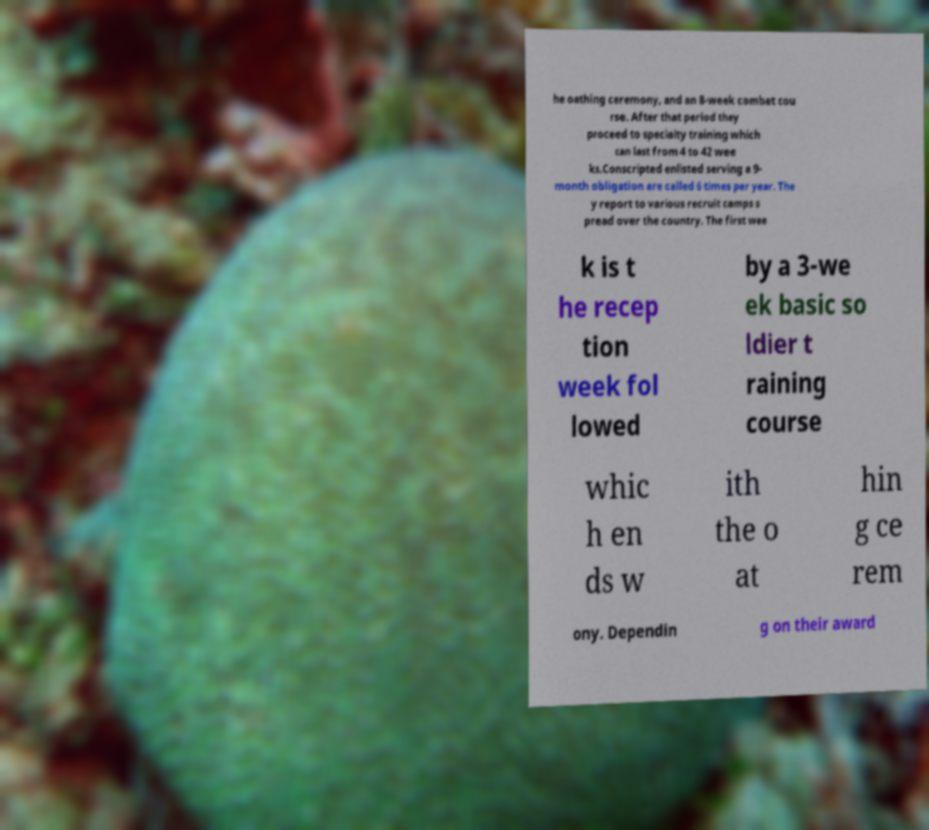Could you assist in decoding the text presented in this image and type it out clearly? he oathing ceremony, and an 8-week combat cou rse. After that period they proceed to specialty training which can last from 4 to 42 wee ks.Conscripted enlisted serving a 9- month obligation are called 6 times per year. The y report to various recruit camps s pread over the country. The first wee k is t he recep tion week fol lowed by a 3-we ek basic so ldier t raining course whic h en ds w ith the o at hin g ce rem ony. Dependin g on their award 